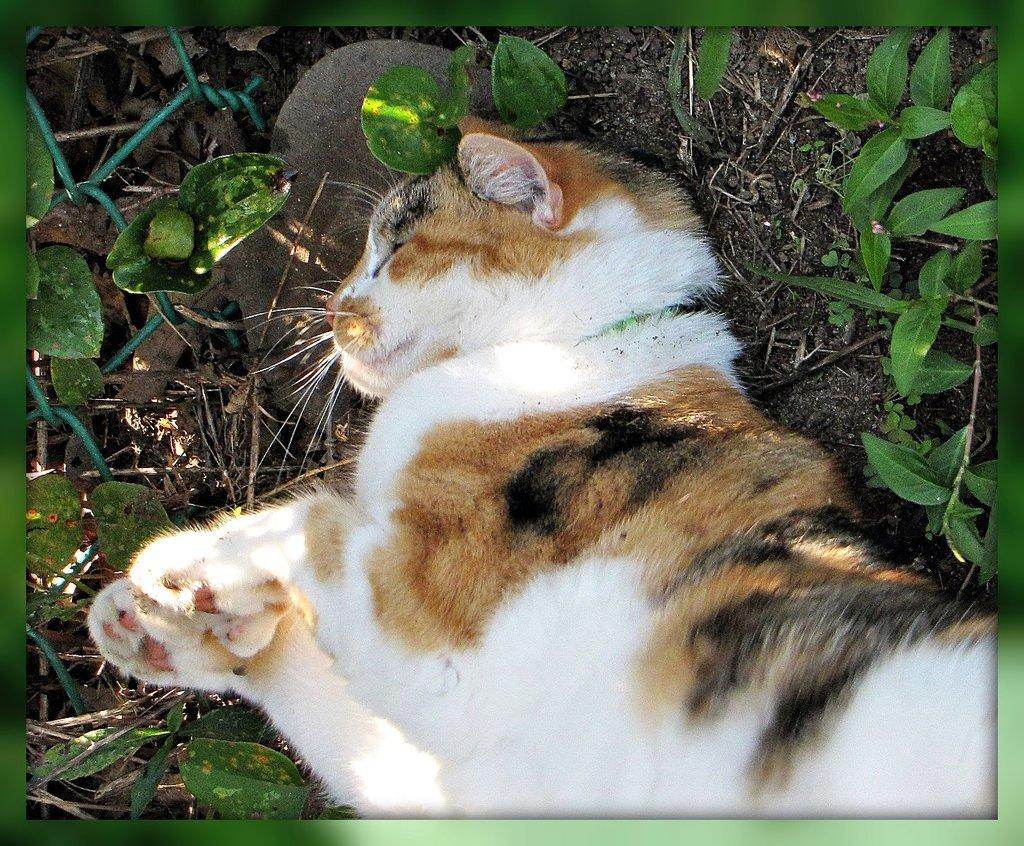What animal is lying on the ground in the image? There is a cat lying on the ground in the image. Where is the cat located in the image? The cat is in the middle of the image. What can be seen in the background of the image? There are small plants in the background of the image. How many cherries are hanging from the yam in the image? There are no cherries or yams present in the image; it features a cat lying on the ground with small plants in the background. 